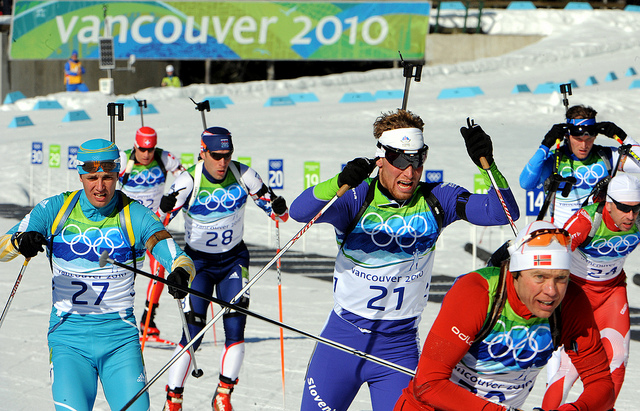Where do you think this event is being held, and what's its significance? This event is being held in Vancouver, Canada, as indicated by the 'Vancouver 2010' banner in the background. The significance lies in the fact that it is part of the Winter Olympic Games, a global event bringing together top athletes from around the world to compete in various winter sports. This event is not just a platform for showcasing athletic prowess but also a celebration of international unity, sportsmanship, and cultural exchange. The Winter Olympics are known for fostering a spirit of competition and camaraderie, making it one of the most prestigious and highly anticipated sporting events globally. Can you create a creative story involving these athletes? In a realm where mythical creatures roamed and magical snowflakes fell from the sky, these athletes weren't just competing for medals, but for the ancient Crystal of Winter. This crystal, hidden deep within the heart of the snowy mountains, had the power to grant the greatest wish to its finder. Each athlete had a unique backstory; one was a prince searching to lift a curse on his kingdom, another an adventurer hoping to bring back her lost love from a distant world. Dressed in their colorful enchanted gear, they navigated through enchanted forests and faced mystical obstacles, from frost giants to enchanted snowdrifts that could swallow them whole. As they raced down the slopes, their determination wasn't just fueled by personal glory but by the hope for a brighter future for their worlds. Amidst the race, alliances formed, secrets were shared, and each step forward was a testament to their bravery and resilience. The image before us is but a glimpse into their adventurous journey, one where every snowflake carried a whisper of magic and every skier a story of heroism. 